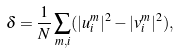<formula> <loc_0><loc_0><loc_500><loc_500>\delta = \frac { 1 } { N } \sum _ { m , i } ( | u ^ { m } _ { i } | ^ { 2 } - | v ^ { m } _ { i } | ^ { 2 } ) ,</formula> 